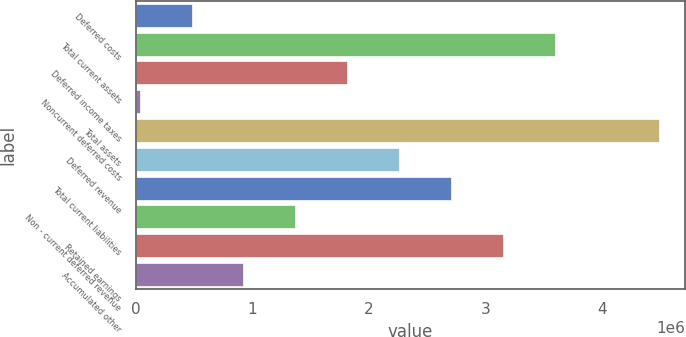Convert chart. <chart><loc_0><loc_0><loc_500><loc_500><bar_chart><fcel>Deferred costs<fcel>Total current assets<fcel>Deferred income taxes<fcel>Noncurrent deferred costs<fcel>Total assets<fcel>Deferred revenue<fcel>Total current liabilities<fcel>Non - current deferred revenue<fcel>Retained earnings<fcel>Accumulated other<nl><fcel>476296<fcel>3.59383e+06<fcel>1.81238e+06<fcel>30934<fcel>4.48455e+06<fcel>2.25774e+06<fcel>2.7031e+06<fcel>1.36702e+06<fcel>3.14846e+06<fcel>921657<nl></chart> 